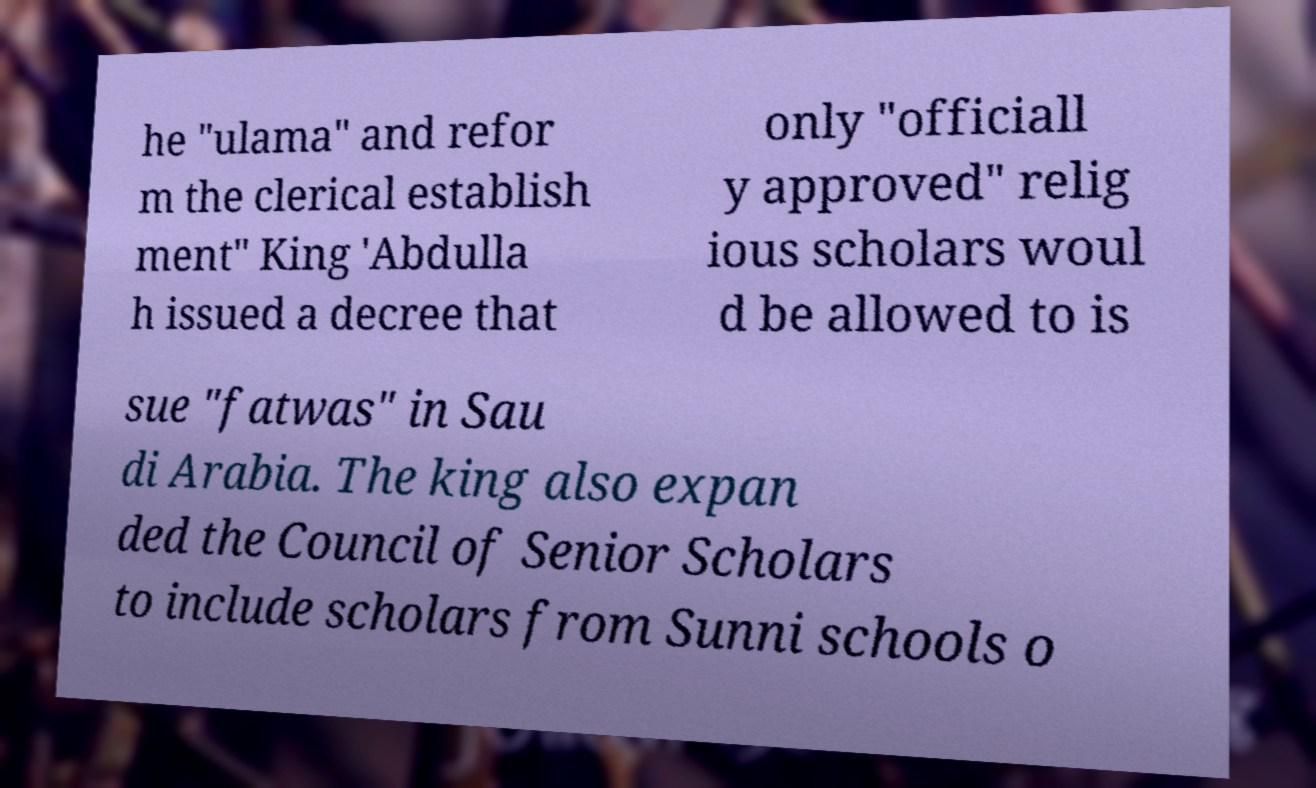I need the written content from this picture converted into text. Can you do that? he "ulama" and refor m the clerical establish ment" King 'Abdulla h issued a decree that only "officiall y approved" relig ious scholars woul d be allowed to is sue "fatwas" in Sau di Arabia. The king also expan ded the Council of Senior Scholars to include scholars from Sunni schools o 